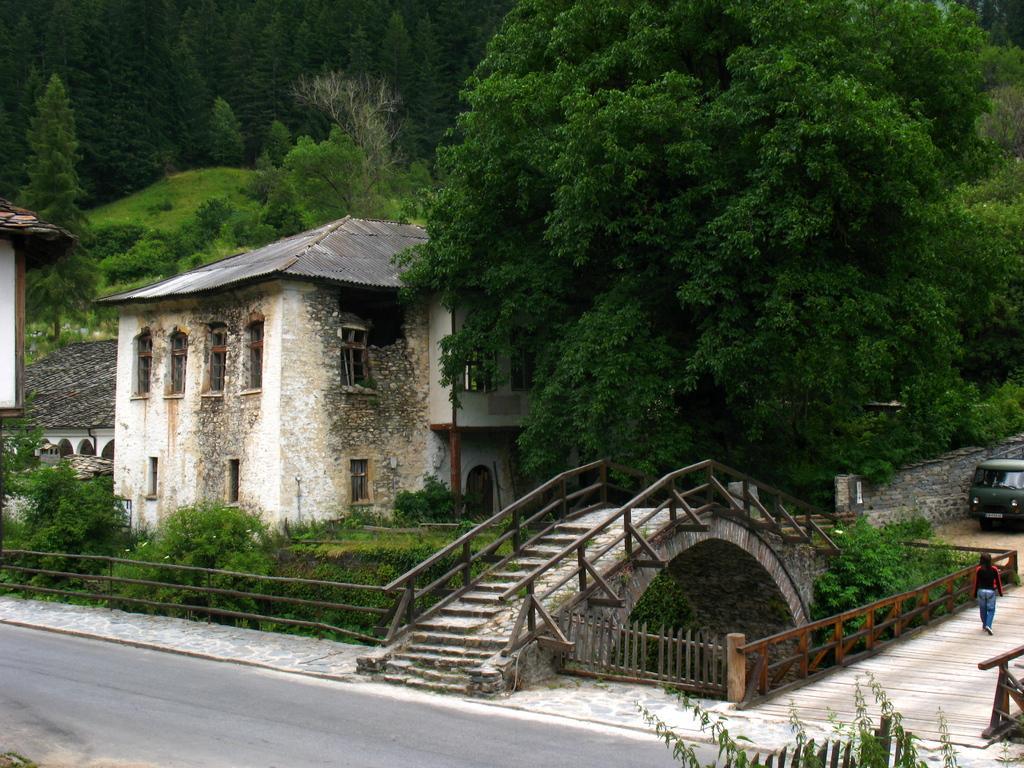Please provide a concise description of this image. In this image in the background there are trees, there is a bridge and there is fence and there is a car and there is a person walking and there are buildings. In the front there is a road and there are leaves and there is fence. 